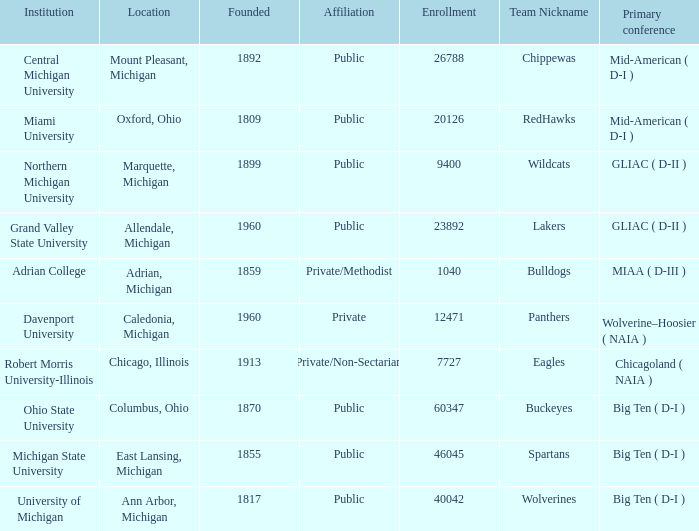What is the enrollment for the Redhawks? 1.0. 